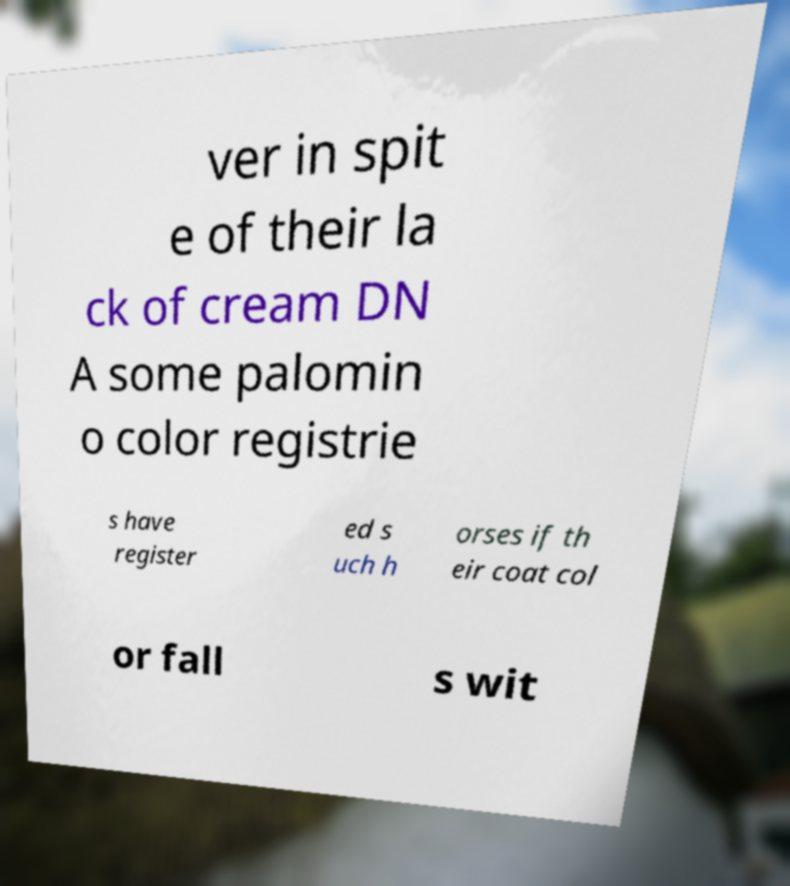For documentation purposes, I need the text within this image transcribed. Could you provide that? ver in spit e of their la ck of cream DN A some palomin o color registrie s have register ed s uch h orses if th eir coat col or fall s wit 